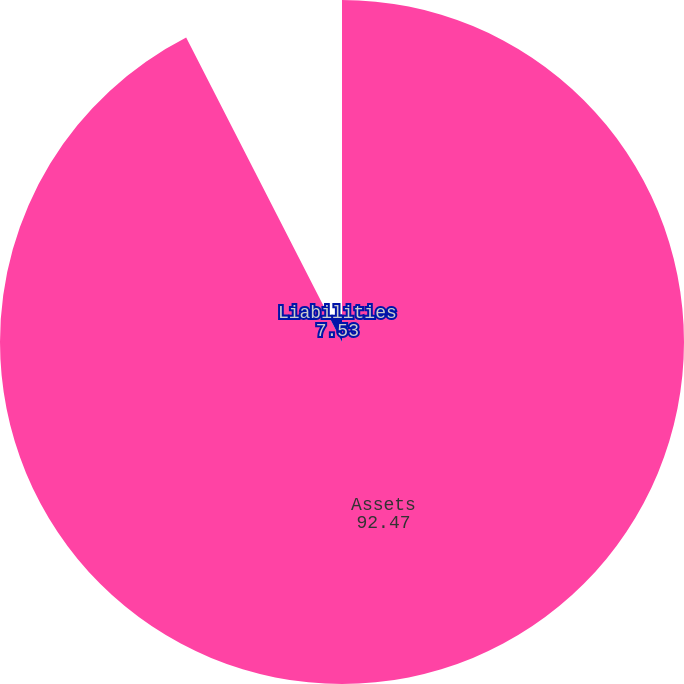Convert chart. <chart><loc_0><loc_0><loc_500><loc_500><pie_chart><fcel>Assets<fcel>Liabilities<nl><fcel>92.47%<fcel>7.53%<nl></chart> 